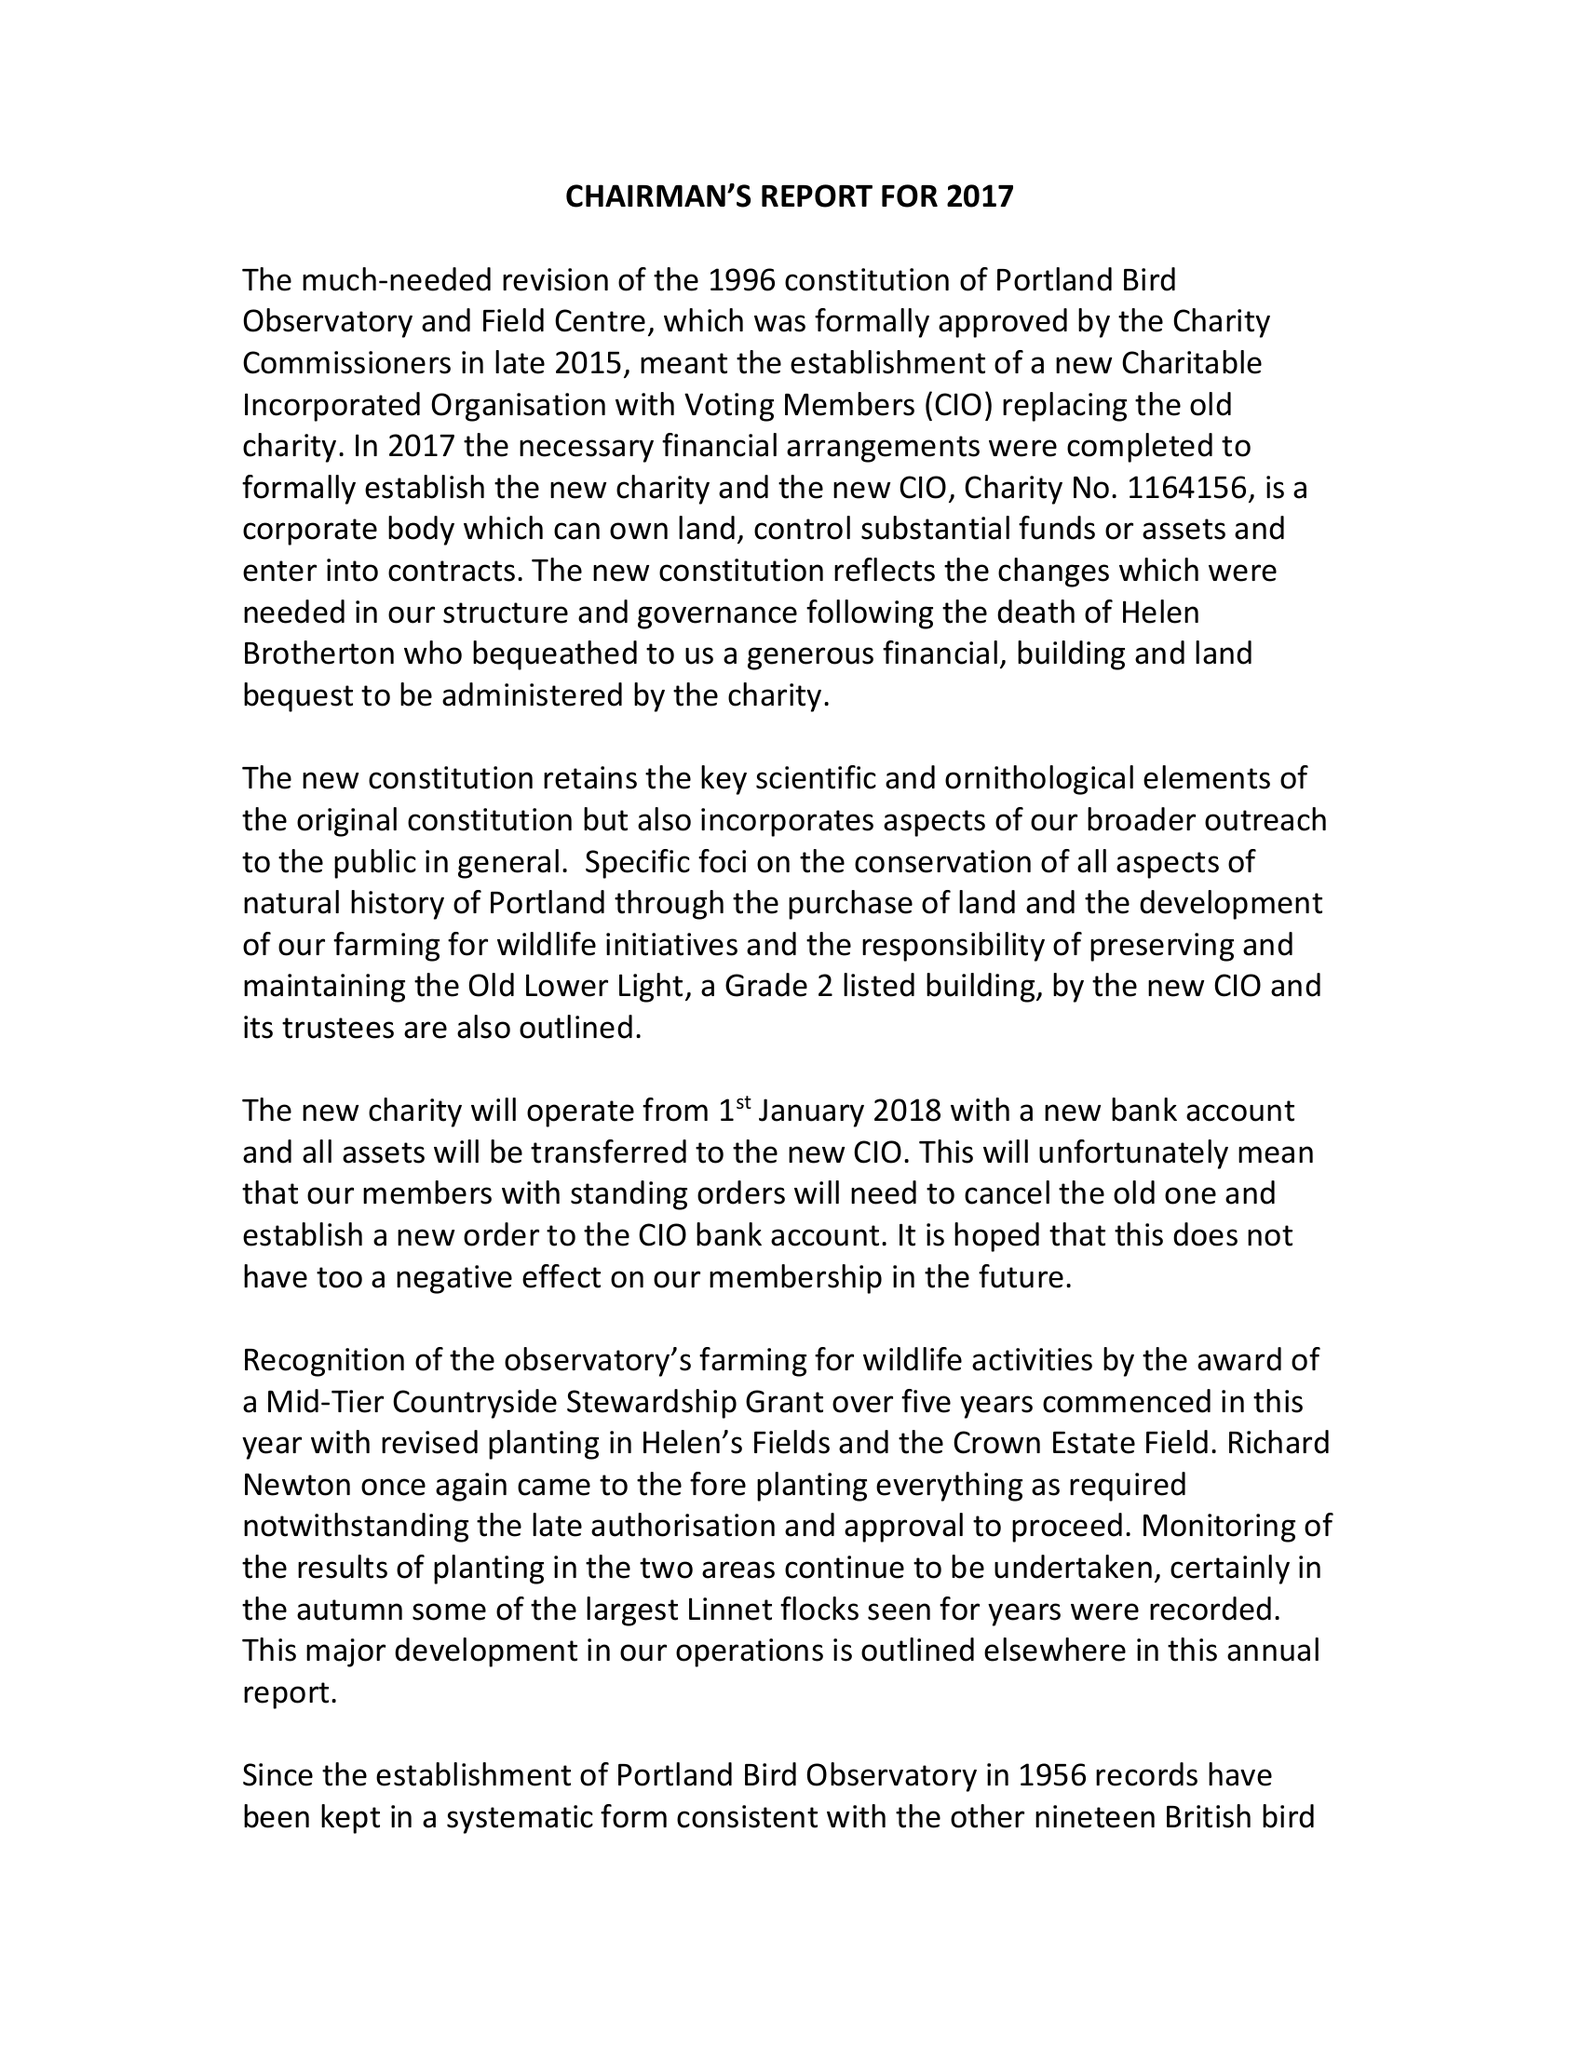What is the value for the income_annually_in_british_pounds?
Answer the question using a single word or phrase. 119895.92 